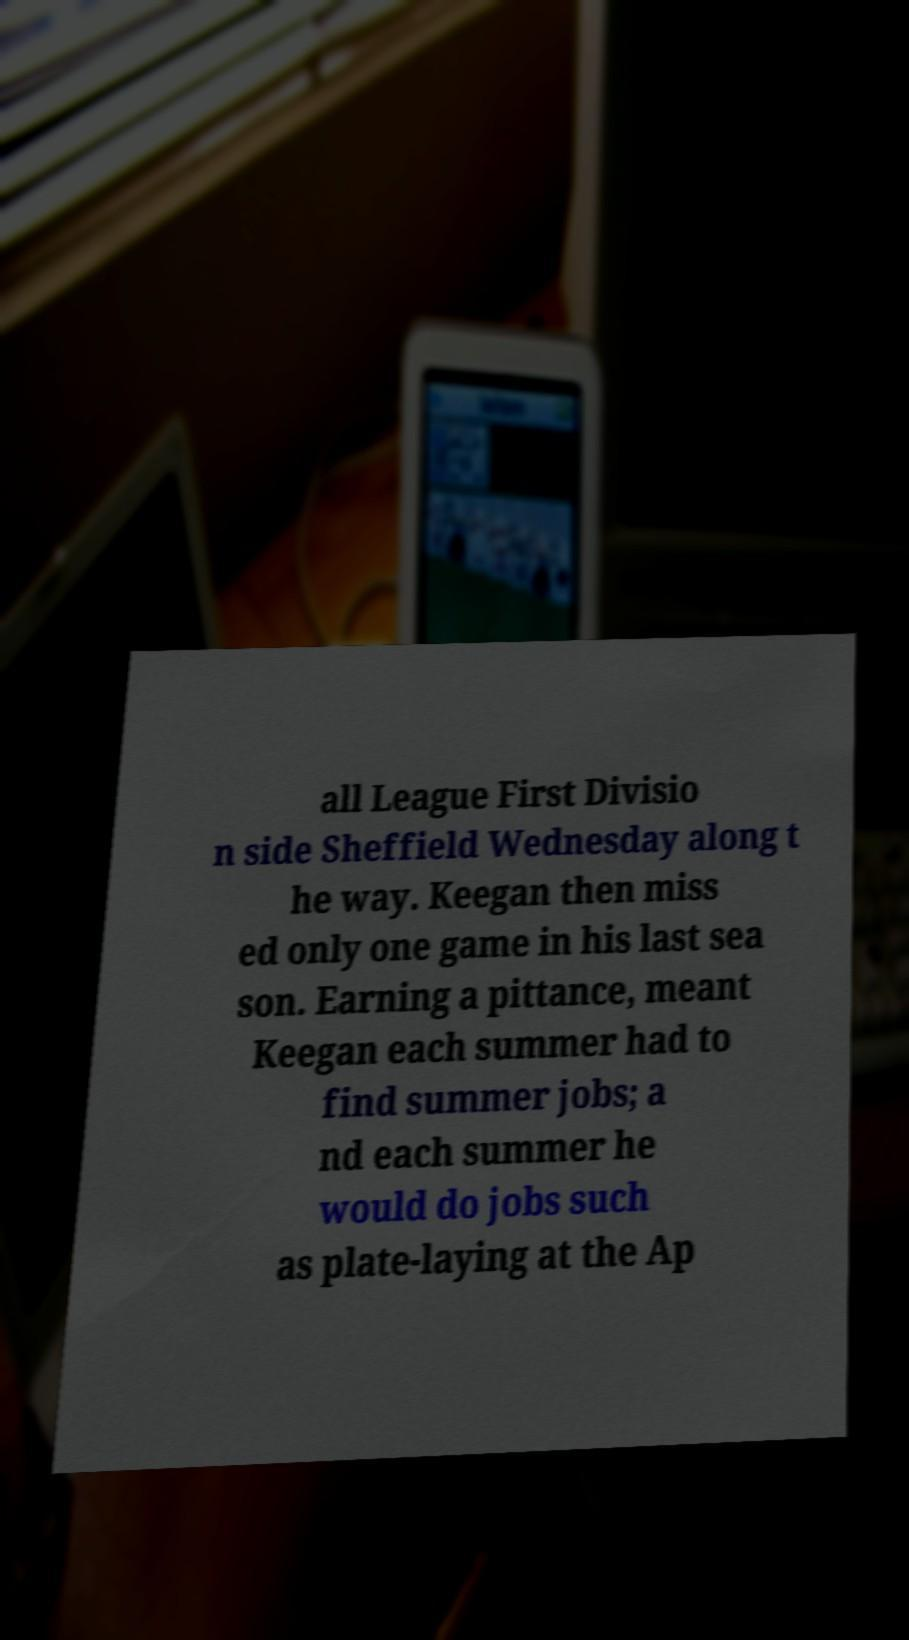Could you extract and type out the text from this image? all League First Divisio n side Sheffield Wednesday along t he way. Keegan then miss ed only one game in his last sea son. Earning a pittance, meant Keegan each summer had to find summer jobs; a nd each summer he would do jobs such as plate-laying at the Ap 